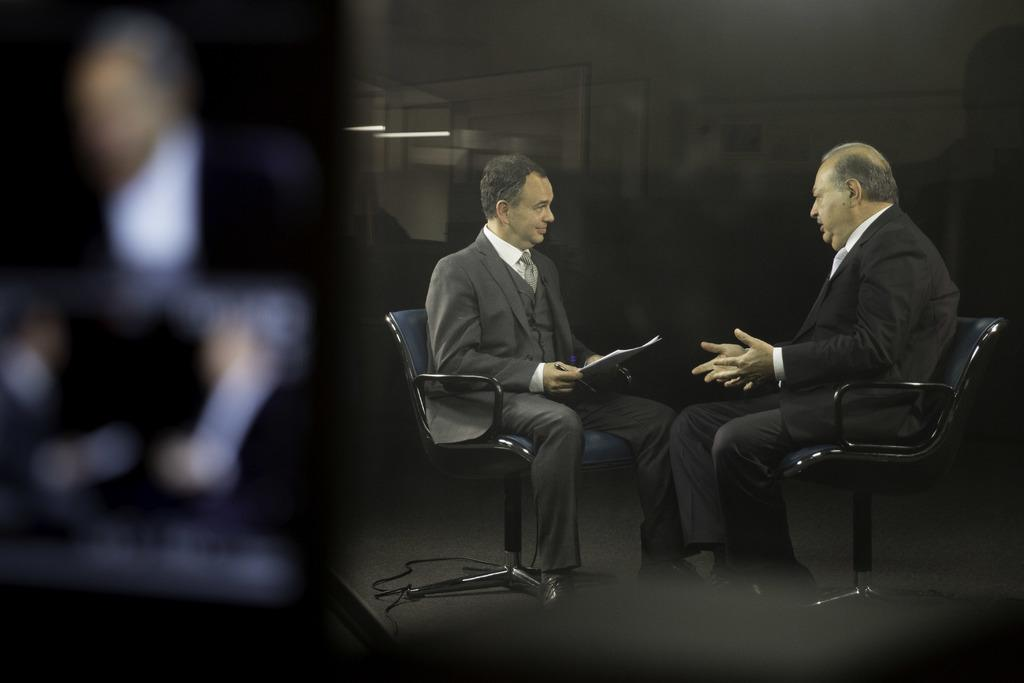How many people are in the image? There are two people in the image. What are the people wearing? Both people are wearing black suits. What are the people doing in the image? The people are sitting on chairs. What type of memory does the expert in the image have? There is no expert present in the image, and therefore no information about their memory can be determined. 